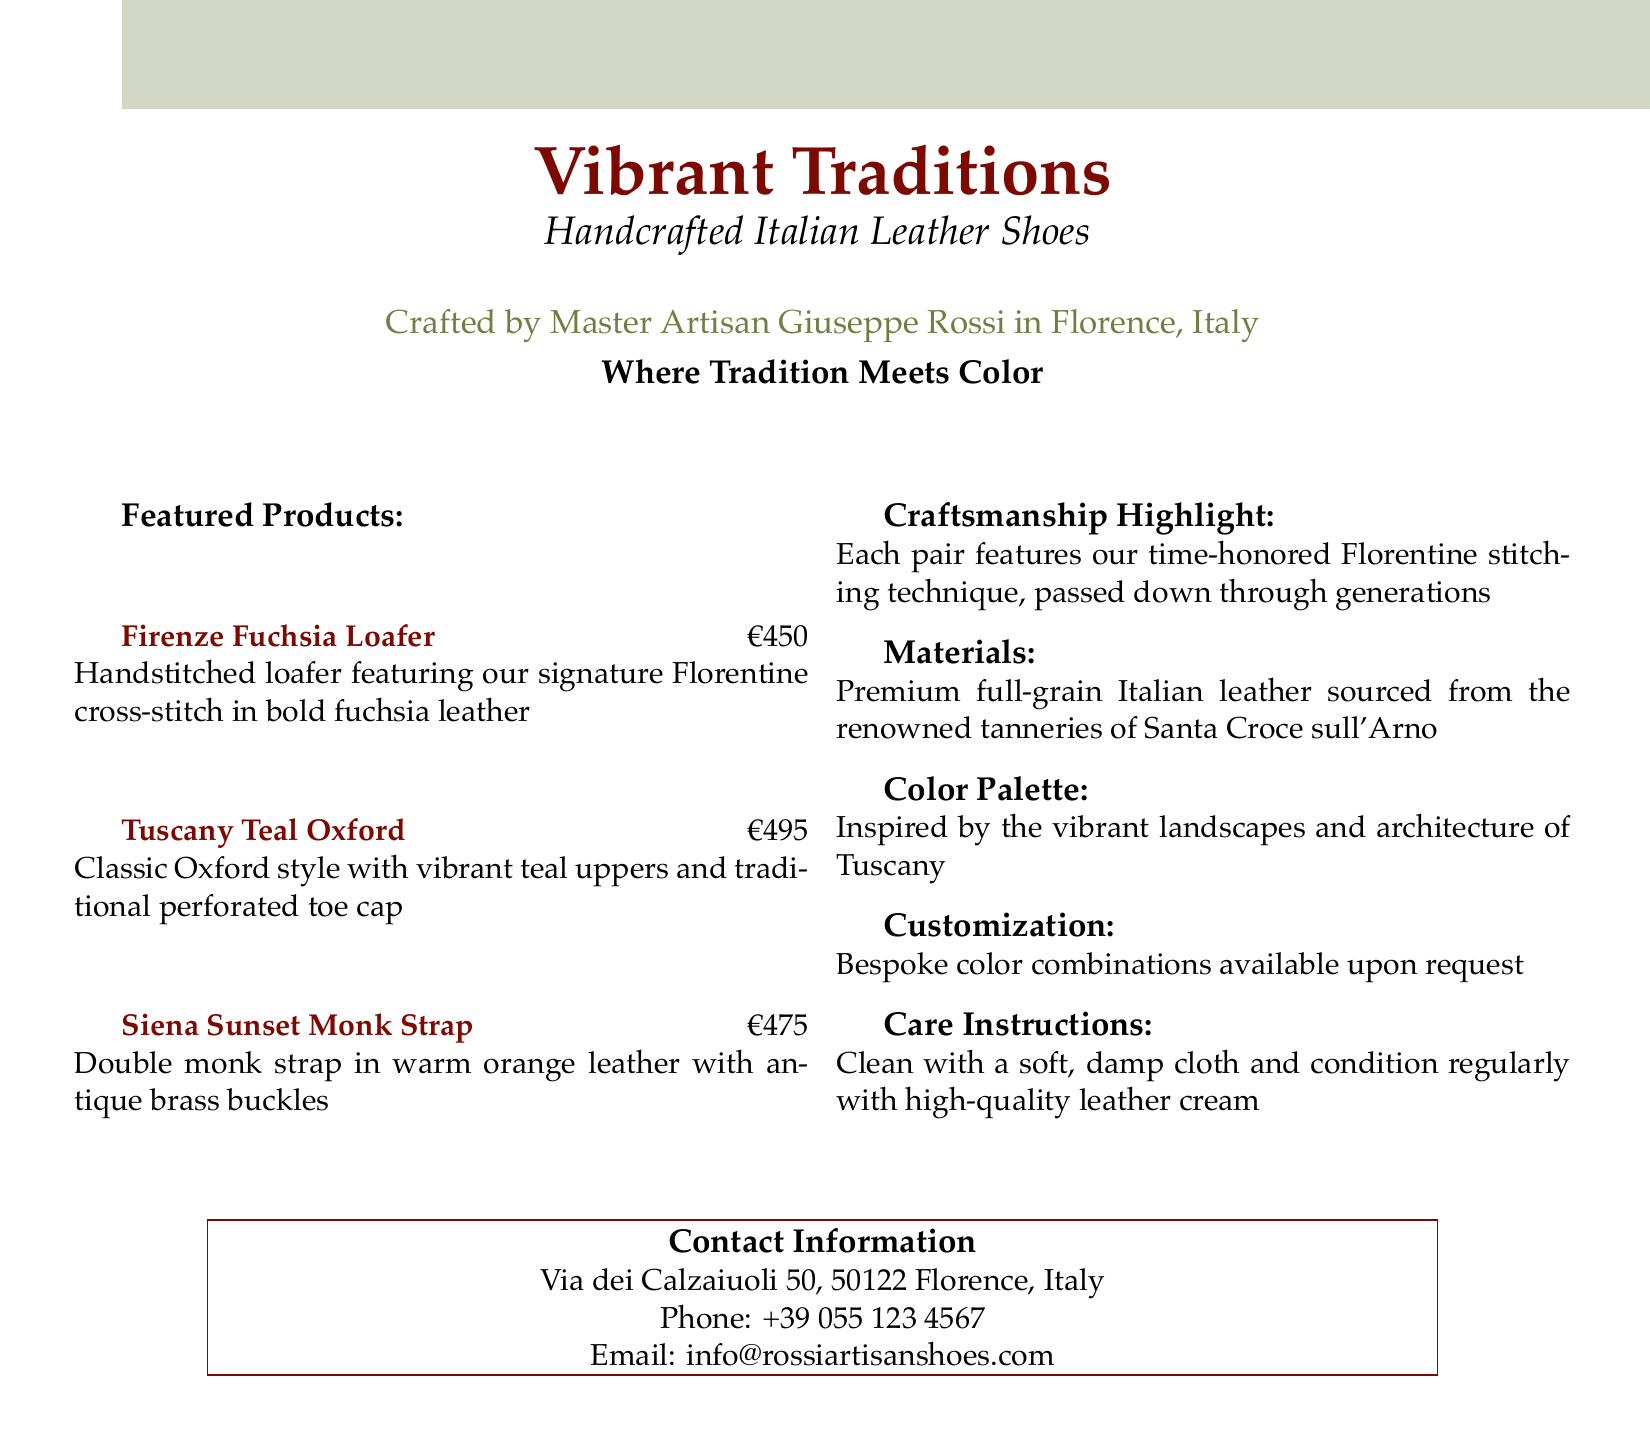What is the name of the artisan? The artisan mentioned in the document is Giuseppe Rossi, who crafts the shoes in Florence, Italy.
Answer: Giuseppe Rossi What is the price of the Tuscany Teal Oxford? The price listed for the Tuscany Teal Oxford shoe is €495.
Answer: €495 Which color is the Siena Sunset Monk Strap made of? The Siena Sunset Monk Strap is made of warm orange leather.
Answer: warm orange What stitching technique is highlighted in the craftsmanship section? The craftsmanship section highlights the Florentine stitching technique that has been passed down through generations.
Answer: Florentine stitching Where is the artisan's shop located? The contact information section states the shop is located at Via dei Calzaiuoli 50, 50122 Florence, Italy.
Answer: Via dei Calzaiuoli 50, 50122 Florence, Italy What type of leather is used for the shoes? The document specifies that the shoes are made from premium full-grain Italian leather.
Answer: premium full-grain Italian leather Is customization available for shoe colors? Yes, the document mentions that bespoke color combinations are available upon request.
Answer: Yes What type of shoe is the Firenze Fuchsia Loafer? The Firenze Fuchsia Loafer is classified as a handstitched loafer in the document.
Answer: handstitched loafer 